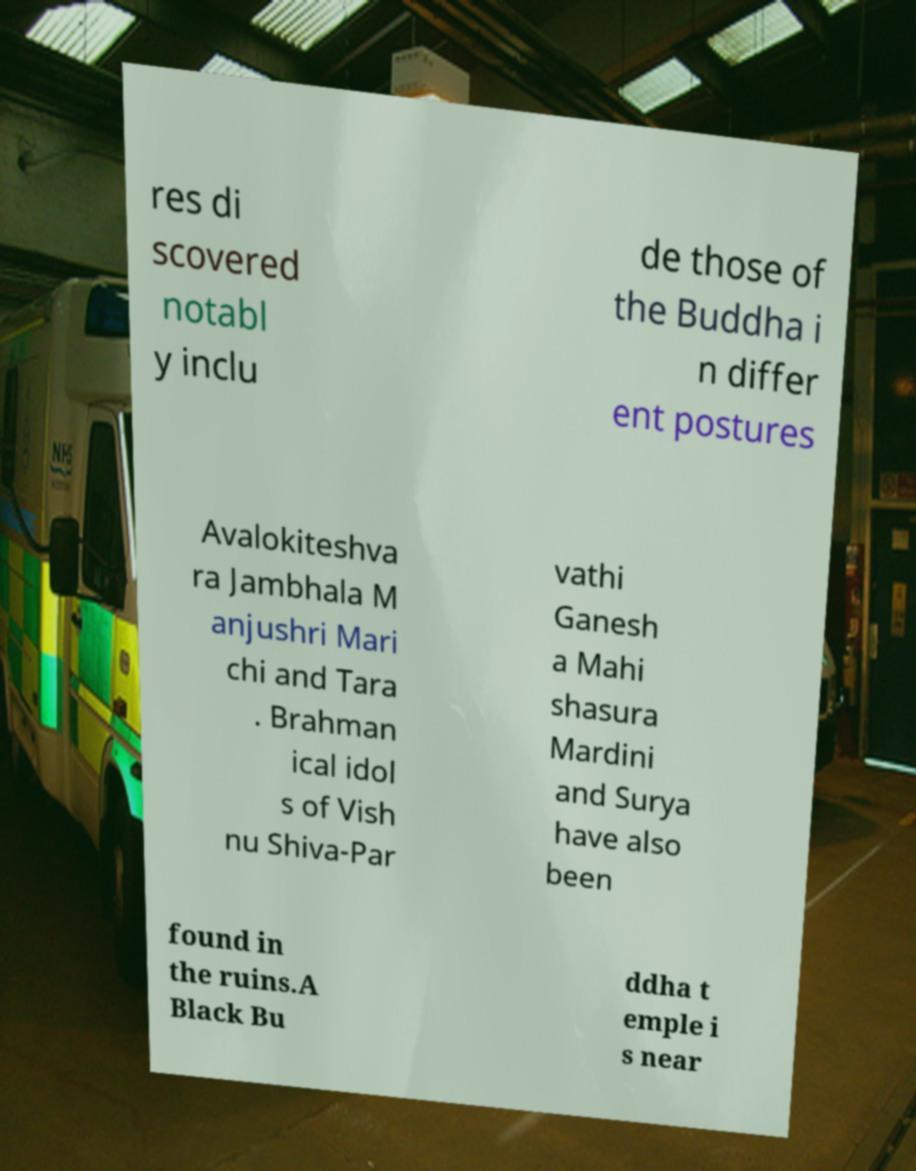Can you read and provide the text displayed in the image?This photo seems to have some interesting text. Can you extract and type it out for me? res di scovered notabl y inclu de those of the Buddha i n differ ent postures Avalokiteshva ra Jambhala M anjushri Mari chi and Tara . Brahman ical idol s of Vish nu Shiva-Par vathi Ganesh a Mahi shasura Mardini and Surya have also been found in the ruins.A Black Bu ddha t emple i s near 